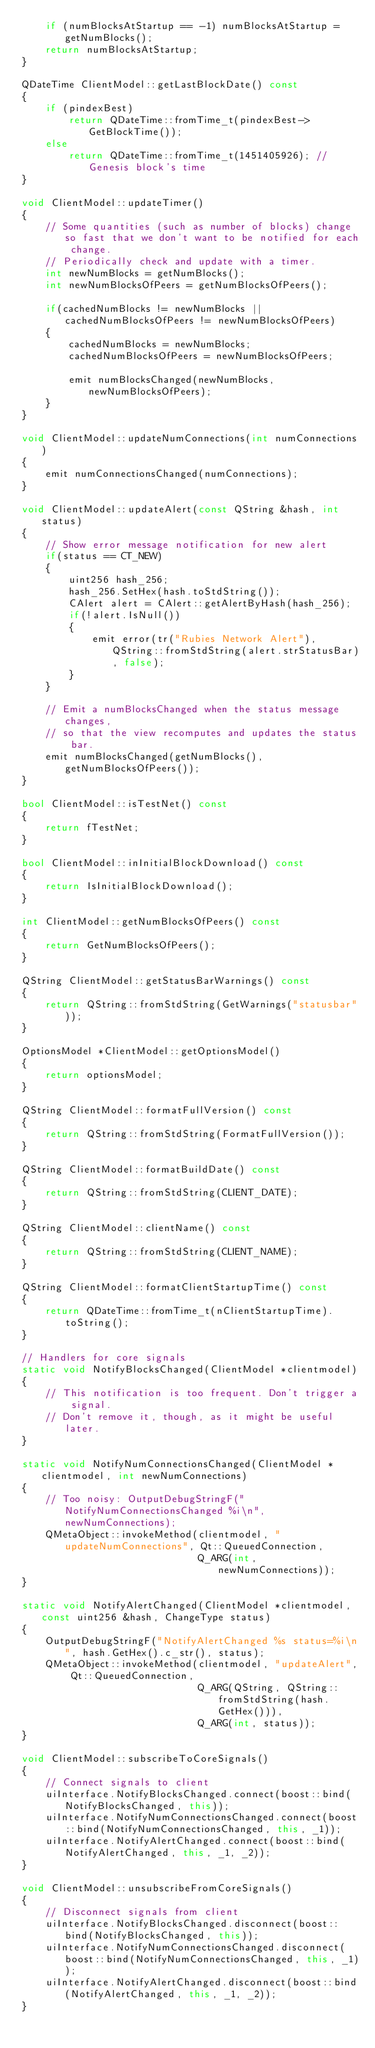<code> <loc_0><loc_0><loc_500><loc_500><_C++_>    if (numBlocksAtStartup == -1) numBlocksAtStartup = getNumBlocks();
    return numBlocksAtStartup;
}

QDateTime ClientModel::getLastBlockDate() const
{
    if (pindexBest)
        return QDateTime::fromTime_t(pindexBest->GetBlockTime());
    else
        return QDateTime::fromTime_t(1451405926); // Genesis block's time
}

void ClientModel::updateTimer()
{
    // Some quantities (such as number of blocks) change so fast that we don't want to be notified for each change.
    // Periodically check and update with a timer.
    int newNumBlocks = getNumBlocks();
    int newNumBlocksOfPeers = getNumBlocksOfPeers();

    if(cachedNumBlocks != newNumBlocks || cachedNumBlocksOfPeers != newNumBlocksOfPeers)
    {
        cachedNumBlocks = newNumBlocks;
        cachedNumBlocksOfPeers = newNumBlocksOfPeers;

        emit numBlocksChanged(newNumBlocks, newNumBlocksOfPeers);
    }
}

void ClientModel::updateNumConnections(int numConnections)
{
    emit numConnectionsChanged(numConnections);
}

void ClientModel::updateAlert(const QString &hash, int status)
{
    // Show error message notification for new alert
    if(status == CT_NEW)
    {
        uint256 hash_256;
        hash_256.SetHex(hash.toStdString());
        CAlert alert = CAlert::getAlertByHash(hash_256);
        if(!alert.IsNull())
        {
            emit error(tr("Rubies Network Alert"), QString::fromStdString(alert.strStatusBar), false);
        }
    }

    // Emit a numBlocksChanged when the status message changes,
    // so that the view recomputes and updates the status bar.
    emit numBlocksChanged(getNumBlocks(), getNumBlocksOfPeers());
}

bool ClientModel::isTestNet() const
{
    return fTestNet;
}

bool ClientModel::inInitialBlockDownload() const
{
    return IsInitialBlockDownload();
}

int ClientModel::getNumBlocksOfPeers() const
{
    return GetNumBlocksOfPeers();
}

QString ClientModel::getStatusBarWarnings() const
{
    return QString::fromStdString(GetWarnings("statusbar"));
}

OptionsModel *ClientModel::getOptionsModel()
{
    return optionsModel;
}

QString ClientModel::formatFullVersion() const
{
    return QString::fromStdString(FormatFullVersion());
}

QString ClientModel::formatBuildDate() const
{
    return QString::fromStdString(CLIENT_DATE);
}

QString ClientModel::clientName() const
{
    return QString::fromStdString(CLIENT_NAME);
}

QString ClientModel::formatClientStartupTime() const
{
    return QDateTime::fromTime_t(nClientStartupTime).toString();
}

// Handlers for core signals
static void NotifyBlocksChanged(ClientModel *clientmodel)
{
    // This notification is too frequent. Don't trigger a signal.
    // Don't remove it, though, as it might be useful later.
}

static void NotifyNumConnectionsChanged(ClientModel *clientmodel, int newNumConnections)
{
    // Too noisy: OutputDebugStringF("NotifyNumConnectionsChanged %i\n", newNumConnections);
    QMetaObject::invokeMethod(clientmodel, "updateNumConnections", Qt::QueuedConnection,
                              Q_ARG(int, newNumConnections));
}

static void NotifyAlertChanged(ClientModel *clientmodel, const uint256 &hash, ChangeType status)
{
    OutputDebugStringF("NotifyAlertChanged %s status=%i\n", hash.GetHex().c_str(), status);
    QMetaObject::invokeMethod(clientmodel, "updateAlert", Qt::QueuedConnection,
                              Q_ARG(QString, QString::fromStdString(hash.GetHex())),
                              Q_ARG(int, status));
}

void ClientModel::subscribeToCoreSignals()
{
    // Connect signals to client
    uiInterface.NotifyBlocksChanged.connect(boost::bind(NotifyBlocksChanged, this));
    uiInterface.NotifyNumConnectionsChanged.connect(boost::bind(NotifyNumConnectionsChanged, this, _1));
    uiInterface.NotifyAlertChanged.connect(boost::bind(NotifyAlertChanged, this, _1, _2));
}

void ClientModel::unsubscribeFromCoreSignals()
{
    // Disconnect signals from client
    uiInterface.NotifyBlocksChanged.disconnect(boost::bind(NotifyBlocksChanged, this));
    uiInterface.NotifyNumConnectionsChanged.disconnect(boost::bind(NotifyNumConnectionsChanged, this, _1));
    uiInterface.NotifyAlertChanged.disconnect(boost::bind(NotifyAlertChanged, this, _1, _2));
}
</code> 